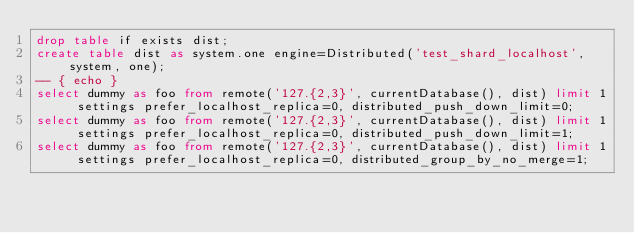<code> <loc_0><loc_0><loc_500><loc_500><_SQL_>drop table if exists dist;
create table dist as system.one engine=Distributed('test_shard_localhost', system, one);
-- { echo }
select dummy as foo from remote('127.{2,3}', currentDatabase(), dist) limit 1 settings prefer_localhost_replica=0, distributed_push_down_limit=0;
select dummy as foo from remote('127.{2,3}', currentDatabase(), dist) limit 1 settings prefer_localhost_replica=0, distributed_push_down_limit=1;
select dummy as foo from remote('127.{2,3}', currentDatabase(), dist) limit 1 settings prefer_localhost_replica=0, distributed_group_by_no_merge=1;
</code> 